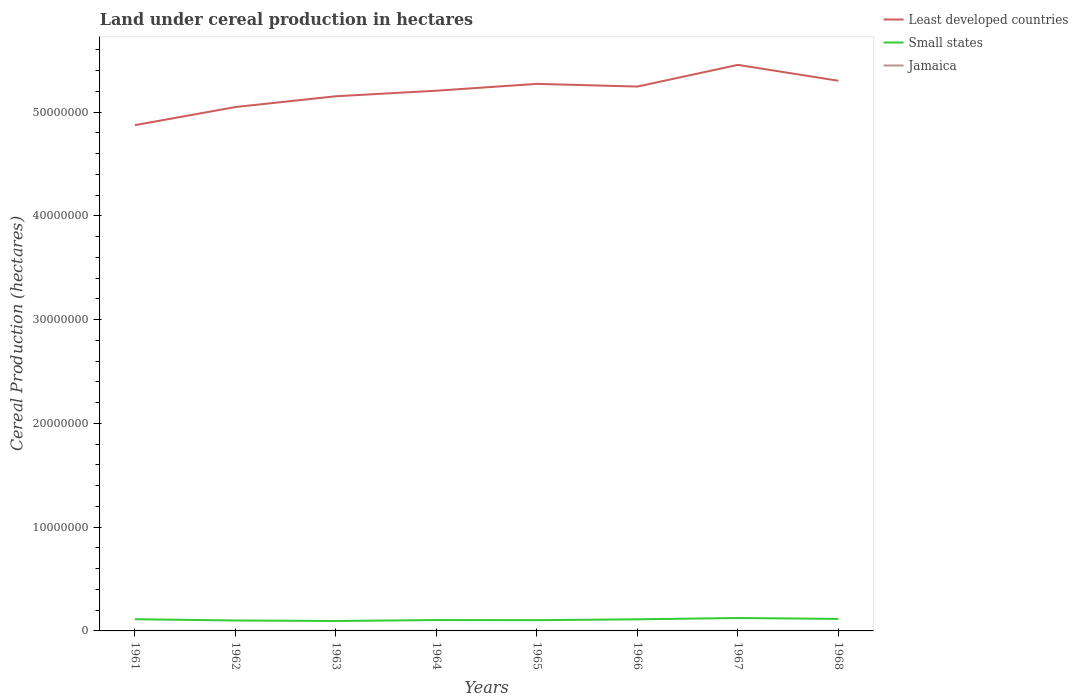Does the line corresponding to Least developed countries intersect with the line corresponding to Small states?
Offer a very short reply. No. Across all years, what is the maximum land under cereal production in Least developed countries?
Ensure brevity in your answer.  4.87e+07. What is the total land under cereal production in Jamaica in the graph?
Offer a very short reply. 1226. What is the difference between the highest and the second highest land under cereal production in Small states?
Offer a very short reply. 2.89e+05. Is the land under cereal production in Small states strictly greater than the land under cereal production in Least developed countries over the years?
Your answer should be compact. Yes. Are the values on the major ticks of Y-axis written in scientific E-notation?
Keep it short and to the point. No. How are the legend labels stacked?
Offer a terse response. Vertical. What is the title of the graph?
Give a very brief answer. Land under cereal production in hectares. Does "Chile" appear as one of the legend labels in the graph?
Offer a terse response. No. What is the label or title of the X-axis?
Offer a very short reply. Years. What is the label or title of the Y-axis?
Provide a succinct answer. Cereal Production (hectares). What is the Cereal Production (hectares) in Least developed countries in 1961?
Offer a very short reply. 4.87e+07. What is the Cereal Production (hectares) in Small states in 1961?
Offer a terse response. 1.13e+06. What is the Cereal Production (hectares) of Jamaica in 1961?
Your answer should be very brief. 9712. What is the Cereal Production (hectares) of Least developed countries in 1962?
Your response must be concise. 5.05e+07. What is the Cereal Production (hectares) of Small states in 1962?
Your answer should be compact. 1.01e+06. What is the Cereal Production (hectares) in Jamaica in 1962?
Give a very brief answer. 8579. What is the Cereal Production (hectares) of Least developed countries in 1963?
Your response must be concise. 5.15e+07. What is the Cereal Production (hectares) of Small states in 1963?
Make the answer very short. 9.56e+05. What is the Cereal Production (hectares) in Jamaica in 1963?
Provide a succinct answer. 8619. What is the Cereal Production (hectares) in Least developed countries in 1964?
Your answer should be compact. 5.21e+07. What is the Cereal Production (hectares) in Small states in 1964?
Your response must be concise. 1.05e+06. What is the Cereal Production (hectares) in Jamaica in 1964?
Offer a terse response. 5960. What is the Cereal Production (hectares) of Least developed countries in 1965?
Offer a terse response. 5.27e+07. What is the Cereal Production (hectares) of Small states in 1965?
Provide a succinct answer. 1.04e+06. What is the Cereal Production (hectares) in Jamaica in 1965?
Your response must be concise. 4816. What is the Cereal Production (hectares) of Least developed countries in 1966?
Your response must be concise. 5.25e+07. What is the Cereal Production (hectares) in Small states in 1966?
Your answer should be compact. 1.12e+06. What is the Cereal Production (hectares) in Jamaica in 1966?
Ensure brevity in your answer.  5985. What is the Cereal Production (hectares) of Least developed countries in 1967?
Give a very brief answer. 5.46e+07. What is the Cereal Production (hectares) in Small states in 1967?
Keep it short and to the point. 1.25e+06. What is the Cereal Production (hectares) in Jamaica in 1967?
Offer a very short reply. 3590. What is the Cereal Production (hectares) in Least developed countries in 1968?
Your answer should be very brief. 5.30e+07. What is the Cereal Production (hectares) in Small states in 1968?
Provide a succinct answer. 1.16e+06. What is the Cereal Production (hectares) in Jamaica in 1968?
Keep it short and to the point. 3980. Across all years, what is the maximum Cereal Production (hectares) of Least developed countries?
Provide a succinct answer. 5.46e+07. Across all years, what is the maximum Cereal Production (hectares) in Small states?
Keep it short and to the point. 1.25e+06. Across all years, what is the maximum Cereal Production (hectares) of Jamaica?
Keep it short and to the point. 9712. Across all years, what is the minimum Cereal Production (hectares) of Least developed countries?
Provide a short and direct response. 4.87e+07. Across all years, what is the minimum Cereal Production (hectares) in Small states?
Ensure brevity in your answer.  9.56e+05. Across all years, what is the minimum Cereal Production (hectares) in Jamaica?
Your answer should be compact. 3590. What is the total Cereal Production (hectares) in Least developed countries in the graph?
Provide a succinct answer. 4.16e+08. What is the total Cereal Production (hectares) in Small states in the graph?
Your response must be concise. 8.70e+06. What is the total Cereal Production (hectares) in Jamaica in the graph?
Keep it short and to the point. 5.12e+04. What is the difference between the Cereal Production (hectares) of Least developed countries in 1961 and that in 1962?
Your answer should be very brief. -1.75e+06. What is the difference between the Cereal Production (hectares) in Small states in 1961 and that in 1962?
Offer a very short reply. 1.22e+05. What is the difference between the Cereal Production (hectares) in Jamaica in 1961 and that in 1962?
Ensure brevity in your answer.  1133. What is the difference between the Cereal Production (hectares) in Least developed countries in 1961 and that in 1963?
Ensure brevity in your answer.  -2.79e+06. What is the difference between the Cereal Production (hectares) of Small states in 1961 and that in 1963?
Give a very brief answer. 1.72e+05. What is the difference between the Cereal Production (hectares) in Jamaica in 1961 and that in 1963?
Provide a short and direct response. 1093. What is the difference between the Cereal Production (hectares) in Least developed countries in 1961 and that in 1964?
Ensure brevity in your answer.  -3.32e+06. What is the difference between the Cereal Production (hectares) in Small states in 1961 and that in 1964?
Ensure brevity in your answer.  8.01e+04. What is the difference between the Cereal Production (hectares) of Jamaica in 1961 and that in 1964?
Offer a terse response. 3752. What is the difference between the Cereal Production (hectares) in Least developed countries in 1961 and that in 1965?
Give a very brief answer. -3.98e+06. What is the difference between the Cereal Production (hectares) of Small states in 1961 and that in 1965?
Offer a terse response. 9.19e+04. What is the difference between the Cereal Production (hectares) in Jamaica in 1961 and that in 1965?
Your answer should be very brief. 4896. What is the difference between the Cereal Production (hectares) of Least developed countries in 1961 and that in 1966?
Offer a very short reply. -3.72e+06. What is the difference between the Cereal Production (hectares) of Small states in 1961 and that in 1966?
Ensure brevity in your answer.  9478. What is the difference between the Cereal Production (hectares) of Jamaica in 1961 and that in 1966?
Provide a succinct answer. 3727. What is the difference between the Cereal Production (hectares) of Least developed countries in 1961 and that in 1967?
Make the answer very short. -5.81e+06. What is the difference between the Cereal Production (hectares) in Small states in 1961 and that in 1967?
Your answer should be very brief. -1.18e+05. What is the difference between the Cereal Production (hectares) in Jamaica in 1961 and that in 1967?
Provide a succinct answer. 6122. What is the difference between the Cereal Production (hectares) of Least developed countries in 1961 and that in 1968?
Provide a succinct answer. -4.28e+06. What is the difference between the Cereal Production (hectares) in Small states in 1961 and that in 1968?
Your answer should be very brief. -3.02e+04. What is the difference between the Cereal Production (hectares) of Jamaica in 1961 and that in 1968?
Ensure brevity in your answer.  5732. What is the difference between the Cereal Production (hectares) in Least developed countries in 1962 and that in 1963?
Provide a short and direct response. -1.04e+06. What is the difference between the Cereal Production (hectares) in Small states in 1962 and that in 1963?
Ensure brevity in your answer.  4.94e+04. What is the difference between the Cereal Production (hectares) of Jamaica in 1962 and that in 1963?
Your answer should be very brief. -40. What is the difference between the Cereal Production (hectares) in Least developed countries in 1962 and that in 1964?
Your answer should be compact. -1.57e+06. What is the difference between the Cereal Production (hectares) of Small states in 1962 and that in 1964?
Give a very brief answer. -4.22e+04. What is the difference between the Cereal Production (hectares) of Jamaica in 1962 and that in 1964?
Make the answer very short. 2619. What is the difference between the Cereal Production (hectares) of Least developed countries in 1962 and that in 1965?
Your answer should be very brief. -2.23e+06. What is the difference between the Cereal Production (hectares) of Small states in 1962 and that in 1965?
Keep it short and to the point. -3.04e+04. What is the difference between the Cereal Production (hectares) in Jamaica in 1962 and that in 1965?
Your response must be concise. 3763. What is the difference between the Cereal Production (hectares) of Least developed countries in 1962 and that in 1966?
Provide a short and direct response. -1.97e+06. What is the difference between the Cereal Production (hectares) of Small states in 1962 and that in 1966?
Give a very brief answer. -1.13e+05. What is the difference between the Cereal Production (hectares) in Jamaica in 1962 and that in 1966?
Provide a succinct answer. 2594. What is the difference between the Cereal Production (hectares) in Least developed countries in 1962 and that in 1967?
Offer a very short reply. -4.06e+06. What is the difference between the Cereal Production (hectares) of Small states in 1962 and that in 1967?
Your answer should be very brief. -2.40e+05. What is the difference between the Cereal Production (hectares) in Jamaica in 1962 and that in 1967?
Keep it short and to the point. 4989. What is the difference between the Cereal Production (hectares) of Least developed countries in 1962 and that in 1968?
Give a very brief answer. -2.53e+06. What is the difference between the Cereal Production (hectares) of Small states in 1962 and that in 1968?
Your answer should be compact. -1.53e+05. What is the difference between the Cereal Production (hectares) of Jamaica in 1962 and that in 1968?
Your answer should be compact. 4599. What is the difference between the Cereal Production (hectares) in Least developed countries in 1963 and that in 1964?
Provide a succinct answer. -5.34e+05. What is the difference between the Cereal Production (hectares) of Small states in 1963 and that in 1964?
Ensure brevity in your answer.  -9.16e+04. What is the difference between the Cereal Production (hectares) of Jamaica in 1963 and that in 1964?
Your answer should be compact. 2659. What is the difference between the Cereal Production (hectares) of Least developed countries in 1963 and that in 1965?
Your answer should be very brief. -1.19e+06. What is the difference between the Cereal Production (hectares) of Small states in 1963 and that in 1965?
Your answer should be very brief. -7.98e+04. What is the difference between the Cereal Production (hectares) in Jamaica in 1963 and that in 1965?
Keep it short and to the point. 3803. What is the difference between the Cereal Production (hectares) of Least developed countries in 1963 and that in 1966?
Provide a succinct answer. -9.34e+05. What is the difference between the Cereal Production (hectares) in Small states in 1963 and that in 1966?
Provide a succinct answer. -1.62e+05. What is the difference between the Cereal Production (hectares) of Jamaica in 1963 and that in 1966?
Your response must be concise. 2634. What is the difference between the Cereal Production (hectares) of Least developed countries in 1963 and that in 1967?
Your answer should be very brief. -3.02e+06. What is the difference between the Cereal Production (hectares) of Small states in 1963 and that in 1967?
Provide a succinct answer. -2.89e+05. What is the difference between the Cereal Production (hectares) in Jamaica in 1963 and that in 1967?
Make the answer very short. 5029. What is the difference between the Cereal Production (hectares) of Least developed countries in 1963 and that in 1968?
Provide a short and direct response. -1.49e+06. What is the difference between the Cereal Production (hectares) of Small states in 1963 and that in 1968?
Your answer should be very brief. -2.02e+05. What is the difference between the Cereal Production (hectares) in Jamaica in 1963 and that in 1968?
Provide a short and direct response. 4639. What is the difference between the Cereal Production (hectares) in Least developed countries in 1964 and that in 1965?
Your answer should be very brief. -6.58e+05. What is the difference between the Cereal Production (hectares) in Small states in 1964 and that in 1965?
Your response must be concise. 1.19e+04. What is the difference between the Cereal Production (hectares) in Jamaica in 1964 and that in 1965?
Ensure brevity in your answer.  1144. What is the difference between the Cereal Production (hectares) of Least developed countries in 1964 and that in 1966?
Ensure brevity in your answer.  -3.99e+05. What is the difference between the Cereal Production (hectares) of Small states in 1964 and that in 1966?
Give a very brief answer. -7.06e+04. What is the difference between the Cereal Production (hectares) in Jamaica in 1964 and that in 1966?
Your answer should be very brief. -25. What is the difference between the Cereal Production (hectares) of Least developed countries in 1964 and that in 1967?
Give a very brief answer. -2.49e+06. What is the difference between the Cereal Production (hectares) of Small states in 1964 and that in 1967?
Make the answer very short. -1.98e+05. What is the difference between the Cereal Production (hectares) in Jamaica in 1964 and that in 1967?
Ensure brevity in your answer.  2370. What is the difference between the Cereal Production (hectares) of Least developed countries in 1964 and that in 1968?
Provide a succinct answer. -9.59e+05. What is the difference between the Cereal Production (hectares) in Small states in 1964 and that in 1968?
Make the answer very short. -1.10e+05. What is the difference between the Cereal Production (hectares) in Jamaica in 1964 and that in 1968?
Make the answer very short. 1980. What is the difference between the Cereal Production (hectares) of Least developed countries in 1965 and that in 1966?
Provide a succinct answer. 2.58e+05. What is the difference between the Cereal Production (hectares) in Small states in 1965 and that in 1966?
Provide a short and direct response. -8.25e+04. What is the difference between the Cereal Production (hectares) in Jamaica in 1965 and that in 1966?
Your response must be concise. -1169. What is the difference between the Cereal Production (hectares) in Least developed countries in 1965 and that in 1967?
Offer a terse response. -1.83e+06. What is the difference between the Cereal Production (hectares) of Small states in 1965 and that in 1967?
Ensure brevity in your answer.  -2.10e+05. What is the difference between the Cereal Production (hectares) of Jamaica in 1965 and that in 1967?
Ensure brevity in your answer.  1226. What is the difference between the Cereal Production (hectares) of Least developed countries in 1965 and that in 1968?
Your response must be concise. -3.01e+05. What is the difference between the Cereal Production (hectares) in Small states in 1965 and that in 1968?
Your response must be concise. -1.22e+05. What is the difference between the Cereal Production (hectares) of Jamaica in 1965 and that in 1968?
Provide a short and direct response. 836. What is the difference between the Cereal Production (hectares) of Least developed countries in 1966 and that in 1967?
Give a very brief answer. -2.09e+06. What is the difference between the Cereal Production (hectares) of Small states in 1966 and that in 1967?
Ensure brevity in your answer.  -1.27e+05. What is the difference between the Cereal Production (hectares) in Jamaica in 1966 and that in 1967?
Give a very brief answer. 2395. What is the difference between the Cereal Production (hectares) in Least developed countries in 1966 and that in 1968?
Provide a short and direct response. -5.59e+05. What is the difference between the Cereal Production (hectares) in Small states in 1966 and that in 1968?
Give a very brief answer. -3.97e+04. What is the difference between the Cereal Production (hectares) of Jamaica in 1966 and that in 1968?
Keep it short and to the point. 2005. What is the difference between the Cereal Production (hectares) in Least developed countries in 1967 and that in 1968?
Your response must be concise. 1.53e+06. What is the difference between the Cereal Production (hectares) in Small states in 1967 and that in 1968?
Ensure brevity in your answer.  8.75e+04. What is the difference between the Cereal Production (hectares) of Jamaica in 1967 and that in 1968?
Your answer should be compact. -390. What is the difference between the Cereal Production (hectares) of Least developed countries in 1961 and the Cereal Production (hectares) of Small states in 1962?
Provide a succinct answer. 4.77e+07. What is the difference between the Cereal Production (hectares) in Least developed countries in 1961 and the Cereal Production (hectares) in Jamaica in 1962?
Your answer should be compact. 4.87e+07. What is the difference between the Cereal Production (hectares) of Small states in 1961 and the Cereal Production (hectares) of Jamaica in 1962?
Your response must be concise. 1.12e+06. What is the difference between the Cereal Production (hectares) in Least developed countries in 1961 and the Cereal Production (hectares) in Small states in 1963?
Your answer should be compact. 4.78e+07. What is the difference between the Cereal Production (hectares) in Least developed countries in 1961 and the Cereal Production (hectares) in Jamaica in 1963?
Provide a succinct answer. 4.87e+07. What is the difference between the Cereal Production (hectares) in Small states in 1961 and the Cereal Production (hectares) in Jamaica in 1963?
Make the answer very short. 1.12e+06. What is the difference between the Cereal Production (hectares) in Least developed countries in 1961 and the Cereal Production (hectares) in Small states in 1964?
Provide a succinct answer. 4.77e+07. What is the difference between the Cereal Production (hectares) in Least developed countries in 1961 and the Cereal Production (hectares) in Jamaica in 1964?
Ensure brevity in your answer.  4.87e+07. What is the difference between the Cereal Production (hectares) in Small states in 1961 and the Cereal Production (hectares) in Jamaica in 1964?
Keep it short and to the point. 1.12e+06. What is the difference between the Cereal Production (hectares) in Least developed countries in 1961 and the Cereal Production (hectares) in Small states in 1965?
Provide a succinct answer. 4.77e+07. What is the difference between the Cereal Production (hectares) in Least developed countries in 1961 and the Cereal Production (hectares) in Jamaica in 1965?
Provide a succinct answer. 4.87e+07. What is the difference between the Cereal Production (hectares) of Small states in 1961 and the Cereal Production (hectares) of Jamaica in 1965?
Your answer should be compact. 1.12e+06. What is the difference between the Cereal Production (hectares) of Least developed countries in 1961 and the Cereal Production (hectares) of Small states in 1966?
Your answer should be very brief. 4.76e+07. What is the difference between the Cereal Production (hectares) of Least developed countries in 1961 and the Cereal Production (hectares) of Jamaica in 1966?
Give a very brief answer. 4.87e+07. What is the difference between the Cereal Production (hectares) in Small states in 1961 and the Cereal Production (hectares) in Jamaica in 1966?
Your answer should be very brief. 1.12e+06. What is the difference between the Cereal Production (hectares) in Least developed countries in 1961 and the Cereal Production (hectares) in Small states in 1967?
Your answer should be compact. 4.75e+07. What is the difference between the Cereal Production (hectares) in Least developed countries in 1961 and the Cereal Production (hectares) in Jamaica in 1967?
Your answer should be compact. 4.87e+07. What is the difference between the Cereal Production (hectares) in Small states in 1961 and the Cereal Production (hectares) in Jamaica in 1967?
Your answer should be very brief. 1.12e+06. What is the difference between the Cereal Production (hectares) of Least developed countries in 1961 and the Cereal Production (hectares) of Small states in 1968?
Your response must be concise. 4.76e+07. What is the difference between the Cereal Production (hectares) of Least developed countries in 1961 and the Cereal Production (hectares) of Jamaica in 1968?
Provide a succinct answer. 4.87e+07. What is the difference between the Cereal Production (hectares) of Small states in 1961 and the Cereal Production (hectares) of Jamaica in 1968?
Offer a terse response. 1.12e+06. What is the difference between the Cereal Production (hectares) in Least developed countries in 1962 and the Cereal Production (hectares) in Small states in 1963?
Keep it short and to the point. 4.95e+07. What is the difference between the Cereal Production (hectares) in Least developed countries in 1962 and the Cereal Production (hectares) in Jamaica in 1963?
Offer a very short reply. 5.05e+07. What is the difference between the Cereal Production (hectares) of Small states in 1962 and the Cereal Production (hectares) of Jamaica in 1963?
Your answer should be very brief. 9.97e+05. What is the difference between the Cereal Production (hectares) in Least developed countries in 1962 and the Cereal Production (hectares) in Small states in 1964?
Provide a short and direct response. 4.94e+07. What is the difference between the Cereal Production (hectares) in Least developed countries in 1962 and the Cereal Production (hectares) in Jamaica in 1964?
Provide a succinct answer. 5.05e+07. What is the difference between the Cereal Production (hectares) in Small states in 1962 and the Cereal Production (hectares) in Jamaica in 1964?
Provide a succinct answer. 1.00e+06. What is the difference between the Cereal Production (hectares) in Least developed countries in 1962 and the Cereal Production (hectares) in Small states in 1965?
Provide a short and direct response. 4.95e+07. What is the difference between the Cereal Production (hectares) in Least developed countries in 1962 and the Cereal Production (hectares) in Jamaica in 1965?
Provide a short and direct response. 5.05e+07. What is the difference between the Cereal Production (hectares) in Small states in 1962 and the Cereal Production (hectares) in Jamaica in 1965?
Make the answer very short. 1.00e+06. What is the difference between the Cereal Production (hectares) in Least developed countries in 1962 and the Cereal Production (hectares) in Small states in 1966?
Provide a short and direct response. 4.94e+07. What is the difference between the Cereal Production (hectares) of Least developed countries in 1962 and the Cereal Production (hectares) of Jamaica in 1966?
Offer a terse response. 5.05e+07. What is the difference between the Cereal Production (hectares) of Small states in 1962 and the Cereal Production (hectares) of Jamaica in 1966?
Your response must be concise. 1.00e+06. What is the difference between the Cereal Production (hectares) in Least developed countries in 1962 and the Cereal Production (hectares) in Small states in 1967?
Offer a terse response. 4.92e+07. What is the difference between the Cereal Production (hectares) of Least developed countries in 1962 and the Cereal Production (hectares) of Jamaica in 1967?
Offer a very short reply. 5.05e+07. What is the difference between the Cereal Production (hectares) in Small states in 1962 and the Cereal Production (hectares) in Jamaica in 1967?
Make the answer very short. 1.00e+06. What is the difference between the Cereal Production (hectares) in Least developed countries in 1962 and the Cereal Production (hectares) in Small states in 1968?
Offer a very short reply. 4.93e+07. What is the difference between the Cereal Production (hectares) in Least developed countries in 1962 and the Cereal Production (hectares) in Jamaica in 1968?
Provide a short and direct response. 5.05e+07. What is the difference between the Cereal Production (hectares) of Small states in 1962 and the Cereal Production (hectares) of Jamaica in 1968?
Your answer should be compact. 1.00e+06. What is the difference between the Cereal Production (hectares) in Least developed countries in 1963 and the Cereal Production (hectares) in Small states in 1964?
Provide a short and direct response. 5.05e+07. What is the difference between the Cereal Production (hectares) of Least developed countries in 1963 and the Cereal Production (hectares) of Jamaica in 1964?
Provide a succinct answer. 5.15e+07. What is the difference between the Cereal Production (hectares) of Small states in 1963 and the Cereal Production (hectares) of Jamaica in 1964?
Keep it short and to the point. 9.50e+05. What is the difference between the Cereal Production (hectares) of Least developed countries in 1963 and the Cereal Production (hectares) of Small states in 1965?
Your answer should be compact. 5.05e+07. What is the difference between the Cereal Production (hectares) of Least developed countries in 1963 and the Cereal Production (hectares) of Jamaica in 1965?
Give a very brief answer. 5.15e+07. What is the difference between the Cereal Production (hectares) of Small states in 1963 and the Cereal Production (hectares) of Jamaica in 1965?
Ensure brevity in your answer.  9.51e+05. What is the difference between the Cereal Production (hectares) of Least developed countries in 1963 and the Cereal Production (hectares) of Small states in 1966?
Your response must be concise. 5.04e+07. What is the difference between the Cereal Production (hectares) in Least developed countries in 1963 and the Cereal Production (hectares) in Jamaica in 1966?
Give a very brief answer. 5.15e+07. What is the difference between the Cereal Production (hectares) of Small states in 1963 and the Cereal Production (hectares) of Jamaica in 1966?
Provide a succinct answer. 9.50e+05. What is the difference between the Cereal Production (hectares) in Least developed countries in 1963 and the Cereal Production (hectares) in Small states in 1967?
Your answer should be compact. 5.03e+07. What is the difference between the Cereal Production (hectares) in Least developed countries in 1963 and the Cereal Production (hectares) in Jamaica in 1967?
Provide a short and direct response. 5.15e+07. What is the difference between the Cereal Production (hectares) in Small states in 1963 and the Cereal Production (hectares) in Jamaica in 1967?
Offer a terse response. 9.53e+05. What is the difference between the Cereal Production (hectares) of Least developed countries in 1963 and the Cereal Production (hectares) of Small states in 1968?
Give a very brief answer. 5.04e+07. What is the difference between the Cereal Production (hectares) of Least developed countries in 1963 and the Cereal Production (hectares) of Jamaica in 1968?
Offer a terse response. 5.15e+07. What is the difference between the Cereal Production (hectares) in Small states in 1963 and the Cereal Production (hectares) in Jamaica in 1968?
Your response must be concise. 9.52e+05. What is the difference between the Cereal Production (hectares) in Least developed countries in 1964 and the Cereal Production (hectares) in Small states in 1965?
Offer a very short reply. 5.10e+07. What is the difference between the Cereal Production (hectares) in Least developed countries in 1964 and the Cereal Production (hectares) in Jamaica in 1965?
Make the answer very short. 5.21e+07. What is the difference between the Cereal Production (hectares) in Small states in 1964 and the Cereal Production (hectares) in Jamaica in 1965?
Your answer should be compact. 1.04e+06. What is the difference between the Cereal Production (hectares) in Least developed countries in 1964 and the Cereal Production (hectares) in Small states in 1966?
Your response must be concise. 5.09e+07. What is the difference between the Cereal Production (hectares) in Least developed countries in 1964 and the Cereal Production (hectares) in Jamaica in 1966?
Ensure brevity in your answer.  5.21e+07. What is the difference between the Cereal Production (hectares) in Small states in 1964 and the Cereal Production (hectares) in Jamaica in 1966?
Offer a terse response. 1.04e+06. What is the difference between the Cereal Production (hectares) in Least developed countries in 1964 and the Cereal Production (hectares) in Small states in 1967?
Ensure brevity in your answer.  5.08e+07. What is the difference between the Cereal Production (hectares) in Least developed countries in 1964 and the Cereal Production (hectares) in Jamaica in 1967?
Your answer should be very brief. 5.21e+07. What is the difference between the Cereal Production (hectares) of Small states in 1964 and the Cereal Production (hectares) of Jamaica in 1967?
Your response must be concise. 1.04e+06. What is the difference between the Cereal Production (hectares) in Least developed countries in 1964 and the Cereal Production (hectares) in Small states in 1968?
Give a very brief answer. 5.09e+07. What is the difference between the Cereal Production (hectares) of Least developed countries in 1964 and the Cereal Production (hectares) of Jamaica in 1968?
Keep it short and to the point. 5.21e+07. What is the difference between the Cereal Production (hectares) of Small states in 1964 and the Cereal Production (hectares) of Jamaica in 1968?
Make the answer very short. 1.04e+06. What is the difference between the Cereal Production (hectares) of Least developed countries in 1965 and the Cereal Production (hectares) of Small states in 1966?
Your answer should be very brief. 5.16e+07. What is the difference between the Cereal Production (hectares) in Least developed countries in 1965 and the Cereal Production (hectares) in Jamaica in 1966?
Ensure brevity in your answer.  5.27e+07. What is the difference between the Cereal Production (hectares) of Small states in 1965 and the Cereal Production (hectares) of Jamaica in 1966?
Make the answer very short. 1.03e+06. What is the difference between the Cereal Production (hectares) in Least developed countries in 1965 and the Cereal Production (hectares) in Small states in 1967?
Ensure brevity in your answer.  5.15e+07. What is the difference between the Cereal Production (hectares) of Least developed countries in 1965 and the Cereal Production (hectares) of Jamaica in 1967?
Your response must be concise. 5.27e+07. What is the difference between the Cereal Production (hectares) of Small states in 1965 and the Cereal Production (hectares) of Jamaica in 1967?
Ensure brevity in your answer.  1.03e+06. What is the difference between the Cereal Production (hectares) in Least developed countries in 1965 and the Cereal Production (hectares) in Small states in 1968?
Your response must be concise. 5.16e+07. What is the difference between the Cereal Production (hectares) of Least developed countries in 1965 and the Cereal Production (hectares) of Jamaica in 1968?
Make the answer very short. 5.27e+07. What is the difference between the Cereal Production (hectares) of Small states in 1965 and the Cereal Production (hectares) of Jamaica in 1968?
Your response must be concise. 1.03e+06. What is the difference between the Cereal Production (hectares) of Least developed countries in 1966 and the Cereal Production (hectares) of Small states in 1967?
Offer a very short reply. 5.12e+07. What is the difference between the Cereal Production (hectares) of Least developed countries in 1966 and the Cereal Production (hectares) of Jamaica in 1967?
Offer a very short reply. 5.25e+07. What is the difference between the Cereal Production (hectares) in Small states in 1966 and the Cereal Production (hectares) in Jamaica in 1967?
Ensure brevity in your answer.  1.11e+06. What is the difference between the Cereal Production (hectares) of Least developed countries in 1966 and the Cereal Production (hectares) of Small states in 1968?
Provide a short and direct response. 5.13e+07. What is the difference between the Cereal Production (hectares) of Least developed countries in 1966 and the Cereal Production (hectares) of Jamaica in 1968?
Ensure brevity in your answer.  5.25e+07. What is the difference between the Cereal Production (hectares) in Small states in 1966 and the Cereal Production (hectares) in Jamaica in 1968?
Keep it short and to the point. 1.11e+06. What is the difference between the Cereal Production (hectares) of Least developed countries in 1967 and the Cereal Production (hectares) of Small states in 1968?
Ensure brevity in your answer.  5.34e+07. What is the difference between the Cereal Production (hectares) in Least developed countries in 1967 and the Cereal Production (hectares) in Jamaica in 1968?
Ensure brevity in your answer.  5.45e+07. What is the difference between the Cereal Production (hectares) in Small states in 1967 and the Cereal Production (hectares) in Jamaica in 1968?
Offer a very short reply. 1.24e+06. What is the average Cereal Production (hectares) of Least developed countries per year?
Your response must be concise. 5.19e+07. What is the average Cereal Production (hectares) in Small states per year?
Offer a terse response. 1.09e+06. What is the average Cereal Production (hectares) of Jamaica per year?
Provide a succinct answer. 6405.12. In the year 1961, what is the difference between the Cereal Production (hectares) of Least developed countries and Cereal Production (hectares) of Small states?
Provide a short and direct response. 4.76e+07. In the year 1961, what is the difference between the Cereal Production (hectares) in Least developed countries and Cereal Production (hectares) in Jamaica?
Provide a short and direct response. 4.87e+07. In the year 1961, what is the difference between the Cereal Production (hectares) of Small states and Cereal Production (hectares) of Jamaica?
Ensure brevity in your answer.  1.12e+06. In the year 1962, what is the difference between the Cereal Production (hectares) in Least developed countries and Cereal Production (hectares) in Small states?
Provide a succinct answer. 4.95e+07. In the year 1962, what is the difference between the Cereal Production (hectares) in Least developed countries and Cereal Production (hectares) in Jamaica?
Provide a succinct answer. 5.05e+07. In the year 1962, what is the difference between the Cereal Production (hectares) in Small states and Cereal Production (hectares) in Jamaica?
Provide a short and direct response. 9.97e+05. In the year 1963, what is the difference between the Cereal Production (hectares) in Least developed countries and Cereal Production (hectares) in Small states?
Your response must be concise. 5.06e+07. In the year 1963, what is the difference between the Cereal Production (hectares) in Least developed countries and Cereal Production (hectares) in Jamaica?
Provide a short and direct response. 5.15e+07. In the year 1963, what is the difference between the Cereal Production (hectares) of Small states and Cereal Production (hectares) of Jamaica?
Give a very brief answer. 9.48e+05. In the year 1964, what is the difference between the Cereal Production (hectares) of Least developed countries and Cereal Production (hectares) of Small states?
Provide a short and direct response. 5.10e+07. In the year 1964, what is the difference between the Cereal Production (hectares) in Least developed countries and Cereal Production (hectares) in Jamaica?
Give a very brief answer. 5.21e+07. In the year 1964, what is the difference between the Cereal Production (hectares) in Small states and Cereal Production (hectares) in Jamaica?
Make the answer very short. 1.04e+06. In the year 1965, what is the difference between the Cereal Production (hectares) of Least developed countries and Cereal Production (hectares) of Small states?
Your answer should be very brief. 5.17e+07. In the year 1965, what is the difference between the Cereal Production (hectares) in Least developed countries and Cereal Production (hectares) in Jamaica?
Offer a terse response. 5.27e+07. In the year 1965, what is the difference between the Cereal Production (hectares) in Small states and Cereal Production (hectares) in Jamaica?
Keep it short and to the point. 1.03e+06. In the year 1966, what is the difference between the Cereal Production (hectares) of Least developed countries and Cereal Production (hectares) of Small states?
Keep it short and to the point. 5.13e+07. In the year 1966, what is the difference between the Cereal Production (hectares) in Least developed countries and Cereal Production (hectares) in Jamaica?
Ensure brevity in your answer.  5.25e+07. In the year 1966, what is the difference between the Cereal Production (hectares) of Small states and Cereal Production (hectares) of Jamaica?
Provide a short and direct response. 1.11e+06. In the year 1967, what is the difference between the Cereal Production (hectares) of Least developed countries and Cereal Production (hectares) of Small states?
Keep it short and to the point. 5.33e+07. In the year 1967, what is the difference between the Cereal Production (hectares) in Least developed countries and Cereal Production (hectares) in Jamaica?
Ensure brevity in your answer.  5.46e+07. In the year 1967, what is the difference between the Cereal Production (hectares) of Small states and Cereal Production (hectares) of Jamaica?
Give a very brief answer. 1.24e+06. In the year 1968, what is the difference between the Cereal Production (hectares) of Least developed countries and Cereal Production (hectares) of Small states?
Offer a terse response. 5.19e+07. In the year 1968, what is the difference between the Cereal Production (hectares) of Least developed countries and Cereal Production (hectares) of Jamaica?
Offer a terse response. 5.30e+07. In the year 1968, what is the difference between the Cereal Production (hectares) of Small states and Cereal Production (hectares) of Jamaica?
Offer a terse response. 1.15e+06. What is the ratio of the Cereal Production (hectares) of Least developed countries in 1961 to that in 1962?
Offer a terse response. 0.97. What is the ratio of the Cereal Production (hectares) in Small states in 1961 to that in 1962?
Your answer should be compact. 1.12. What is the ratio of the Cereal Production (hectares) in Jamaica in 1961 to that in 1962?
Your answer should be very brief. 1.13. What is the ratio of the Cereal Production (hectares) of Least developed countries in 1961 to that in 1963?
Provide a succinct answer. 0.95. What is the ratio of the Cereal Production (hectares) in Small states in 1961 to that in 1963?
Your answer should be compact. 1.18. What is the ratio of the Cereal Production (hectares) in Jamaica in 1961 to that in 1963?
Your answer should be compact. 1.13. What is the ratio of the Cereal Production (hectares) in Least developed countries in 1961 to that in 1964?
Your answer should be very brief. 0.94. What is the ratio of the Cereal Production (hectares) of Small states in 1961 to that in 1964?
Your response must be concise. 1.08. What is the ratio of the Cereal Production (hectares) of Jamaica in 1961 to that in 1964?
Give a very brief answer. 1.63. What is the ratio of the Cereal Production (hectares) in Least developed countries in 1961 to that in 1965?
Provide a short and direct response. 0.92. What is the ratio of the Cereal Production (hectares) in Small states in 1961 to that in 1965?
Ensure brevity in your answer.  1.09. What is the ratio of the Cereal Production (hectares) in Jamaica in 1961 to that in 1965?
Offer a terse response. 2.02. What is the ratio of the Cereal Production (hectares) of Least developed countries in 1961 to that in 1966?
Provide a short and direct response. 0.93. What is the ratio of the Cereal Production (hectares) in Small states in 1961 to that in 1966?
Keep it short and to the point. 1.01. What is the ratio of the Cereal Production (hectares) in Jamaica in 1961 to that in 1966?
Make the answer very short. 1.62. What is the ratio of the Cereal Production (hectares) of Least developed countries in 1961 to that in 1967?
Your answer should be compact. 0.89. What is the ratio of the Cereal Production (hectares) of Small states in 1961 to that in 1967?
Your answer should be very brief. 0.91. What is the ratio of the Cereal Production (hectares) of Jamaica in 1961 to that in 1967?
Offer a very short reply. 2.71. What is the ratio of the Cereal Production (hectares) in Least developed countries in 1961 to that in 1968?
Your response must be concise. 0.92. What is the ratio of the Cereal Production (hectares) in Small states in 1961 to that in 1968?
Give a very brief answer. 0.97. What is the ratio of the Cereal Production (hectares) in Jamaica in 1961 to that in 1968?
Offer a terse response. 2.44. What is the ratio of the Cereal Production (hectares) in Least developed countries in 1962 to that in 1963?
Your response must be concise. 0.98. What is the ratio of the Cereal Production (hectares) in Small states in 1962 to that in 1963?
Provide a short and direct response. 1.05. What is the ratio of the Cereal Production (hectares) in Jamaica in 1962 to that in 1963?
Your response must be concise. 1. What is the ratio of the Cereal Production (hectares) of Least developed countries in 1962 to that in 1964?
Your response must be concise. 0.97. What is the ratio of the Cereal Production (hectares) of Small states in 1962 to that in 1964?
Ensure brevity in your answer.  0.96. What is the ratio of the Cereal Production (hectares) in Jamaica in 1962 to that in 1964?
Your answer should be compact. 1.44. What is the ratio of the Cereal Production (hectares) of Least developed countries in 1962 to that in 1965?
Offer a very short reply. 0.96. What is the ratio of the Cereal Production (hectares) of Small states in 1962 to that in 1965?
Provide a succinct answer. 0.97. What is the ratio of the Cereal Production (hectares) of Jamaica in 1962 to that in 1965?
Offer a terse response. 1.78. What is the ratio of the Cereal Production (hectares) of Least developed countries in 1962 to that in 1966?
Give a very brief answer. 0.96. What is the ratio of the Cereal Production (hectares) in Small states in 1962 to that in 1966?
Offer a terse response. 0.9. What is the ratio of the Cereal Production (hectares) in Jamaica in 1962 to that in 1966?
Keep it short and to the point. 1.43. What is the ratio of the Cereal Production (hectares) in Least developed countries in 1962 to that in 1967?
Provide a short and direct response. 0.93. What is the ratio of the Cereal Production (hectares) in Small states in 1962 to that in 1967?
Give a very brief answer. 0.81. What is the ratio of the Cereal Production (hectares) of Jamaica in 1962 to that in 1967?
Give a very brief answer. 2.39. What is the ratio of the Cereal Production (hectares) in Least developed countries in 1962 to that in 1968?
Offer a terse response. 0.95. What is the ratio of the Cereal Production (hectares) of Small states in 1962 to that in 1968?
Provide a succinct answer. 0.87. What is the ratio of the Cereal Production (hectares) of Jamaica in 1962 to that in 1968?
Offer a terse response. 2.16. What is the ratio of the Cereal Production (hectares) of Least developed countries in 1963 to that in 1964?
Provide a succinct answer. 0.99. What is the ratio of the Cereal Production (hectares) of Small states in 1963 to that in 1964?
Offer a very short reply. 0.91. What is the ratio of the Cereal Production (hectares) of Jamaica in 1963 to that in 1964?
Provide a succinct answer. 1.45. What is the ratio of the Cereal Production (hectares) in Least developed countries in 1963 to that in 1965?
Make the answer very short. 0.98. What is the ratio of the Cereal Production (hectares) of Small states in 1963 to that in 1965?
Make the answer very short. 0.92. What is the ratio of the Cereal Production (hectares) of Jamaica in 1963 to that in 1965?
Provide a short and direct response. 1.79. What is the ratio of the Cereal Production (hectares) in Least developed countries in 1963 to that in 1966?
Make the answer very short. 0.98. What is the ratio of the Cereal Production (hectares) in Small states in 1963 to that in 1966?
Give a very brief answer. 0.85. What is the ratio of the Cereal Production (hectares) in Jamaica in 1963 to that in 1966?
Your answer should be compact. 1.44. What is the ratio of the Cereal Production (hectares) in Least developed countries in 1963 to that in 1967?
Provide a short and direct response. 0.94. What is the ratio of the Cereal Production (hectares) in Small states in 1963 to that in 1967?
Your answer should be compact. 0.77. What is the ratio of the Cereal Production (hectares) of Jamaica in 1963 to that in 1967?
Your answer should be very brief. 2.4. What is the ratio of the Cereal Production (hectares) of Least developed countries in 1963 to that in 1968?
Give a very brief answer. 0.97. What is the ratio of the Cereal Production (hectares) in Small states in 1963 to that in 1968?
Provide a succinct answer. 0.83. What is the ratio of the Cereal Production (hectares) of Jamaica in 1963 to that in 1968?
Make the answer very short. 2.17. What is the ratio of the Cereal Production (hectares) of Least developed countries in 1964 to that in 1965?
Your answer should be very brief. 0.99. What is the ratio of the Cereal Production (hectares) of Small states in 1964 to that in 1965?
Make the answer very short. 1.01. What is the ratio of the Cereal Production (hectares) of Jamaica in 1964 to that in 1965?
Offer a very short reply. 1.24. What is the ratio of the Cereal Production (hectares) in Least developed countries in 1964 to that in 1966?
Offer a very short reply. 0.99. What is the ratio of the Cereal Production (hectares) of Small states in 1964 to that in 1966?
Offer a very short reply. 0.94. What is the ratio of the Cereal Production (hectares) in Jamaica in 1964 to that in 1966?
Give a very brief answer. 1. What is the ratio of the Cereal Production (hectares) in Least developed countries in 1964 to that in 1967?
Keep it short and to the point. 0.95. What is the ratio of the Cereal Production (hectares) in Small states in 1964 to that in 1967?
Your answer should be very brief. 0.84. What is the ratio of the Cereal Production (hectares) in Jamaica in 1964 to that in 1967?
Give a very brief answer. 1.66. What is the ratio of the Cereal Production (hectares) in Least developed countries in 1964 to that in 1968?
Your answer should be compact. 0.98. What is the ratio of the Cereal Production (hectares) in Small states in 1964 to that in 1968?
Your response must be concise. 0.9. What is the ratio of the Cereal Production (hectares) in Jamaica in 1964 to that in 1968?
Keep it short and to the point. 1.5. What is the ratio of the Cereal Production (hectares) of Least developed countries in 1965 to that in 1966?
Offer a very short reply. 1. What is the ratio of the Cereal Production (hectares) in Small states in 1965 to that in 1966?
Provide a short and direct response. 0.93. What is the ratio of the Cereal Production (hectares) of Jamaica in 1965 to that in 1966?
Your response must be concise. 0.8. What is the ratio of the Cereal Production (hectares) in Least developed countries in 1965 to that in 1967?
Give a very brief answer. 0.97. What is the ratio of the Cereal Production (hectares) of Small states in 1965 to that in 1967?
Keep it short and to the point. 0.83. What is the ratio of the Cereal Production (hectares) in Jamaica in 1965 to that in 1967?
Keep it short and to the point. 1.34. What is the ratio of the Cereal Production (hectares) of Least developed countries in 1965 to that in 1968?
Provide a succinct answer. 0.99. What is the ratio of the Cereal Production (hectares) in Small states in 1965 to that in 1968?
Give a very brief answer. 0.89. What is the ratio of the Cereal Production (hectares) of Jamaica in 1965 to that in 1968?
Ensure brevity in your answer.  1.21. What is the ratio of the Cereal Production (hectares) in Least developed countries in 1966 to that in 1967?
Offer a very short reply. 0.96. What is the ratio of the Cereal Production (hectares) in Small states in 1966 to that in 1967?
Give a very brief answer. 0.9. What is the ratio of the Cereal Production (hectares) of Jamaica in 1966 to that in 1967?
Your response must be concise. 1.67. What is the ratio of the Cereal Production (hectares) of Least developed countries in 1966 to that in 1968?
Give a very brief answer. 0.99. What is the ratio of the Cereal Production (hectares) of Small states in 1966 to that in 1968?
Provide a short and direct response. 0.97. What is the ratio of the Cereal Production (hectares) of Jamaica in 1966 to that in 1968?
Offer a very short reply. 1.5. What is the ratio of the Cereal Production (hectares) of Least developed countries in 1967 to that in 1968?
Your answer should be very brief. 1.03. What is the ratio of the Cereal Production (hectares) in Small states in 1967 to that in 1968?
Offer a terse response. 1.08. What is the ratio of the Cereal Production (hectares) in Jamaica in 1967 to that in 1968?
Provide a succinct answer. 0.9. What is the difference between the highest and the second highest Cereal Production (hectares) of Least developed countries?
Keep it short and to the point. 1.53e+06. What is the difference between the highest and the second highest Cereal Production (hectares) of Small states?
Make the answer very short. 8.75e+04. What is the difference between the highest and the second highest Cereal Production (hectares) in Jamaica?
Provide a succinct answer. 1093. What is the difference between the highest and the lowest Cereal Production (hectares) of Least developed countries?
Your answer should be compact. 5.81e+06. What is the difference between the highest and the lowest Cereal Production (hectares) in Small states?
Your response must be concise. 2.89e+05. What is the difference between the highest and the lowest Cereal Production (hectares) in Jamaica?
Your answer should be very brief. 6122. 